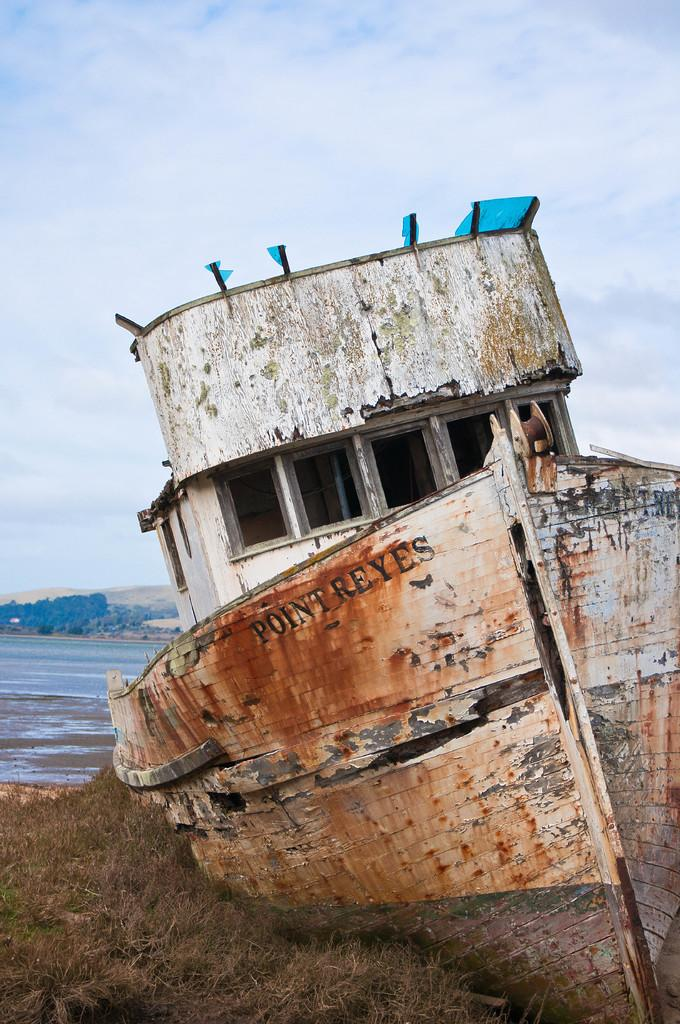What type of terrain is visible in the front of the image? There is grass in the front of the image. What object is located in the front of the image? There is a boat in the front of the image. What can be seen in the background of the image? There is water visible in the background of the image. How would you describe the weather in the image? The sky is cloudy in the background of the image, suggesting a potentially overcast or cloudy day. What type of trouble is the boat experiencing in the image? There is no indication of trouble or any issues with the boat in the image. What angle is the boat positioned at in the image? The angle of the boat cannot be determined from the image alone, as it only provides a two-dimensional representation. 